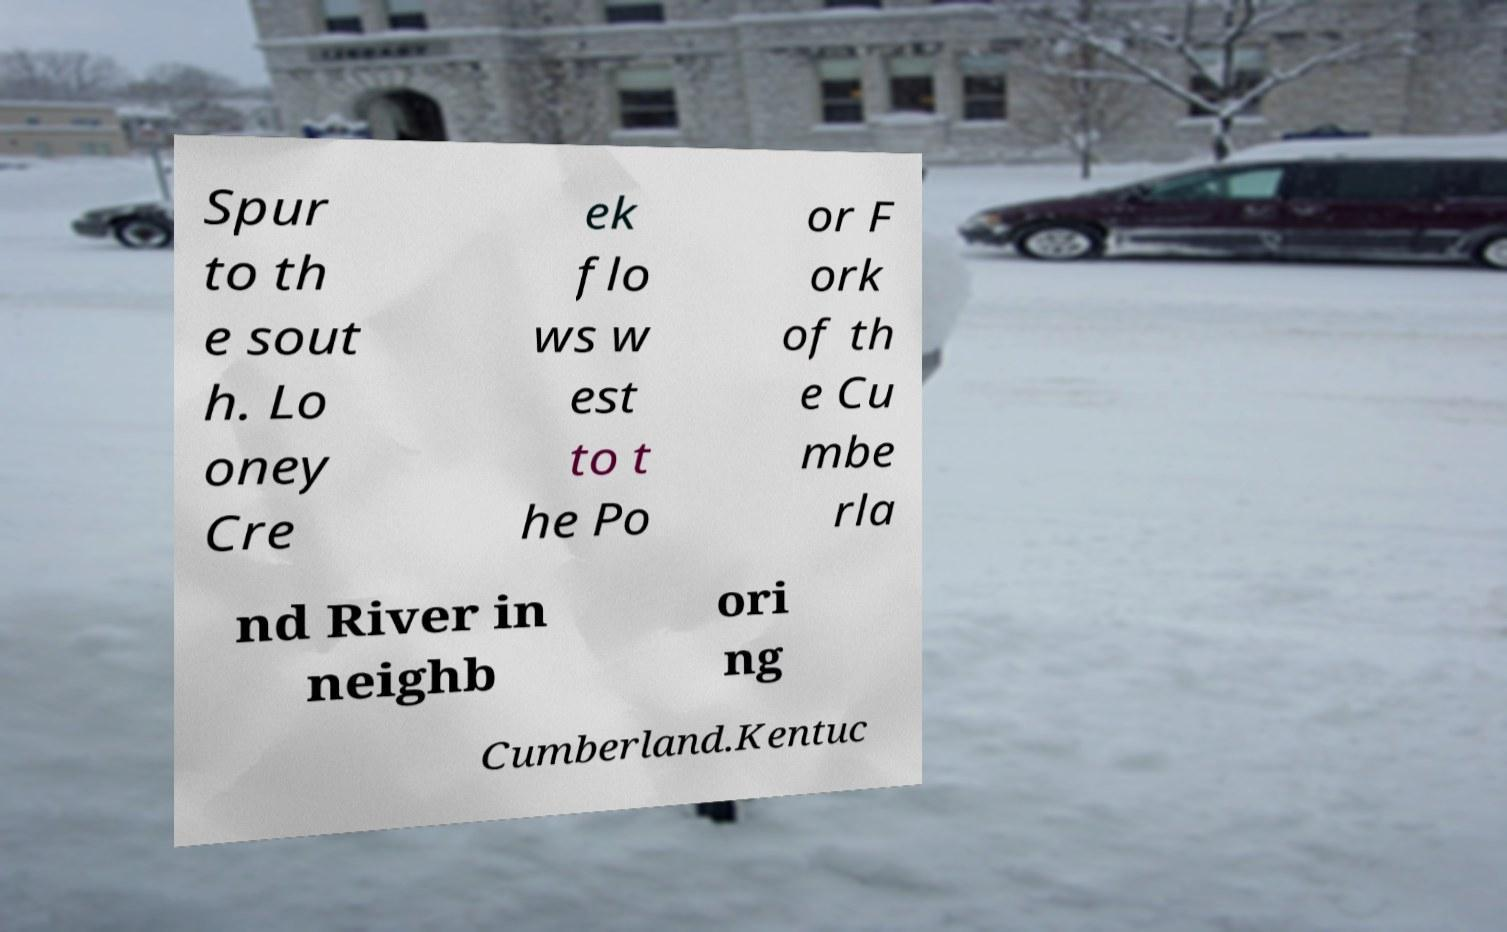There's text embedded in this image that I need extracted. Can you transcribe it verbatim? Spur to th e sout h. Lo oney Cre ek flo ws w est to t he Po or F ork of th e Cu mbe rla nd River in neighb ori ng Cumberland.Kentuc 